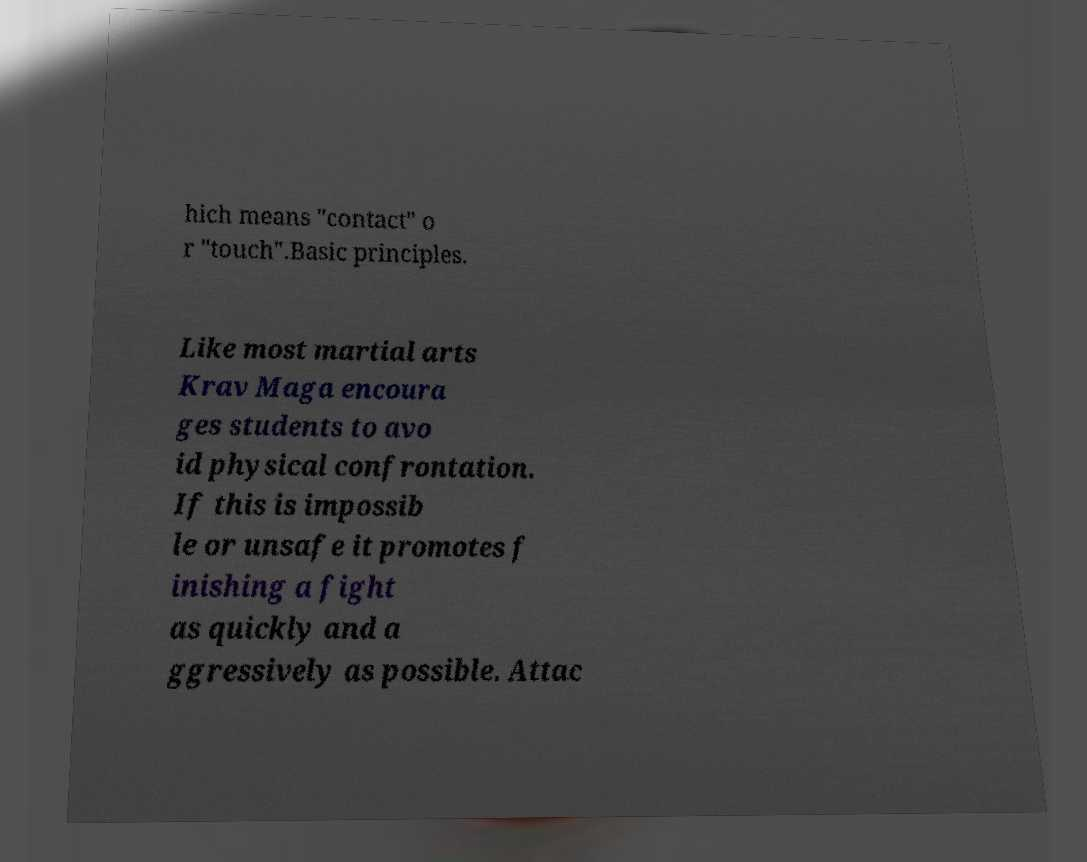Please identify and transcribe the text found in this image. hich means "contact" o r "touch".Basic principles. Like most martial arts Krav Maga encoura ges students to avo id physical confrontation. If this is impossib le or unsafe it promotes f inishing a fight as quickly and a ggressively as possible. Attac 